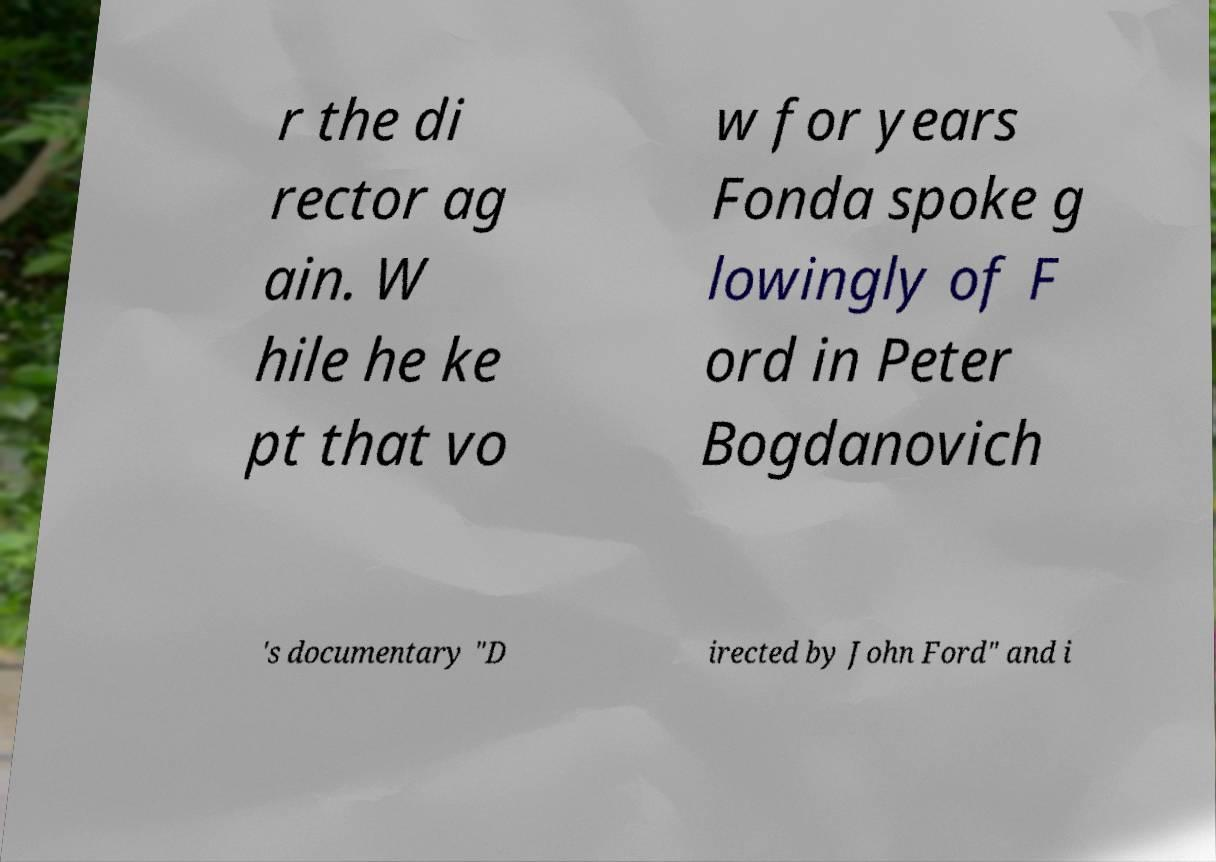Please read and relay the text visible in this image. What does it say? r the di rector ag ain. W hile he ke pt that vo w for years Fonda spoke g lowingly of F ord in Peter Bogdanovich 's documentary "D irected by John Ford" and i 